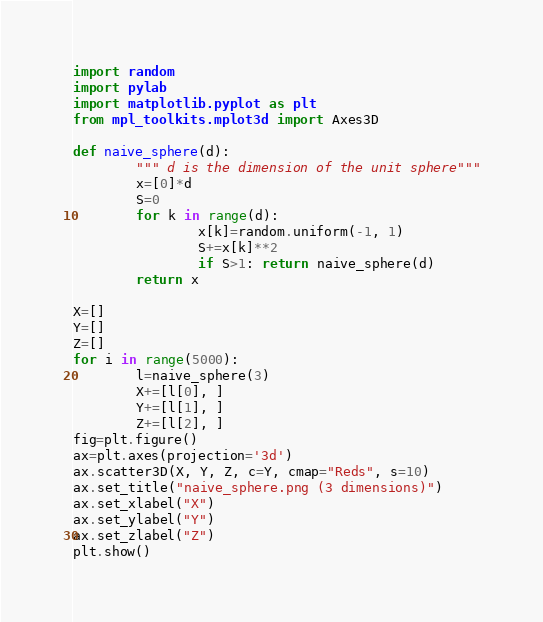Convert code to text. <code><loc_0><loc_0><loc_500><loc_500><_Python_>import random
import pylab
import matplotlib.pyplot as plt
from mpl_toolkits.mplot3d import Axes3D

def naive_sphere(d):
        """ d is the dimension of the unit sphere"""
        x=[0]*d
        S=0
        for k in range(d):
                x[k]=random.uniform(-1, 1)
                S+=x[k]**2
                if S>1: return naive_sphere(d)
        return x

X=[]
Y=[]
Z=[]
for i in range(5000):
        l=naive_sphere(3)
        X+=[l[0], ]
        Y+=[l[1], ]
        Z+=[l[2], ]
fig=plt.figure()
ax=plt.axes(projection='3d')
ax.scatter3D(X, Y, Z, c=Y, cmap="Reds", s=10)
ax.set_title("naive_sphere.png (3 dimensions)")
ax.set_xlabel("X")
ax.set_ylabel("Y")
ax.set_zlabel("Z")
plt.show()</code> 